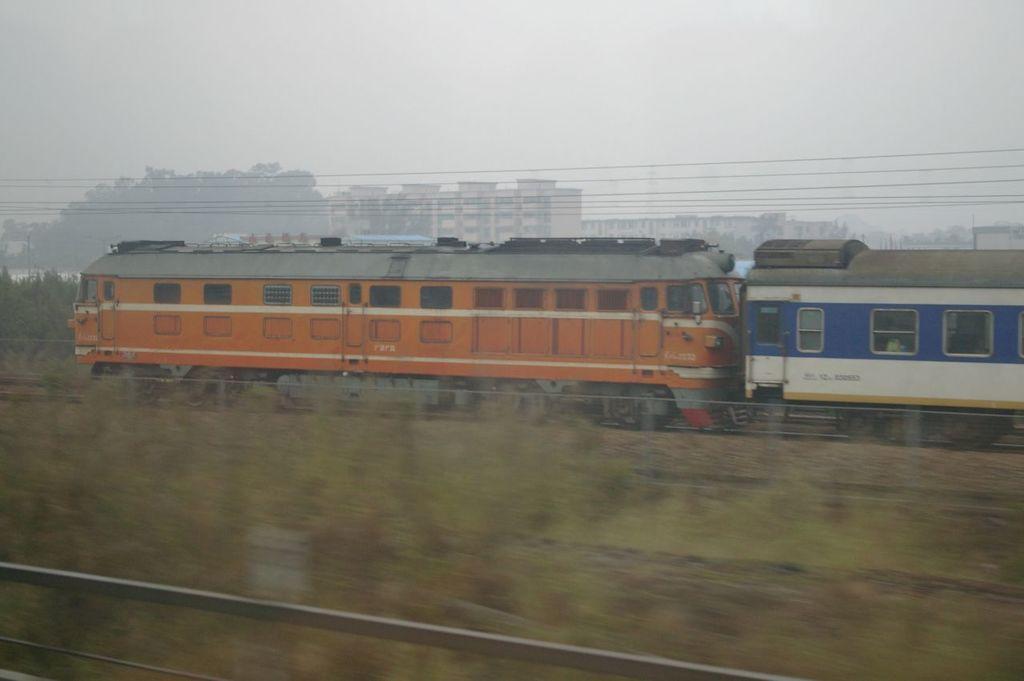Can you describe this image briefly? In this image we can see a train engine and a coach on the tracks, in the background of the image there are buildings, on top of the train there are electrical cables. 